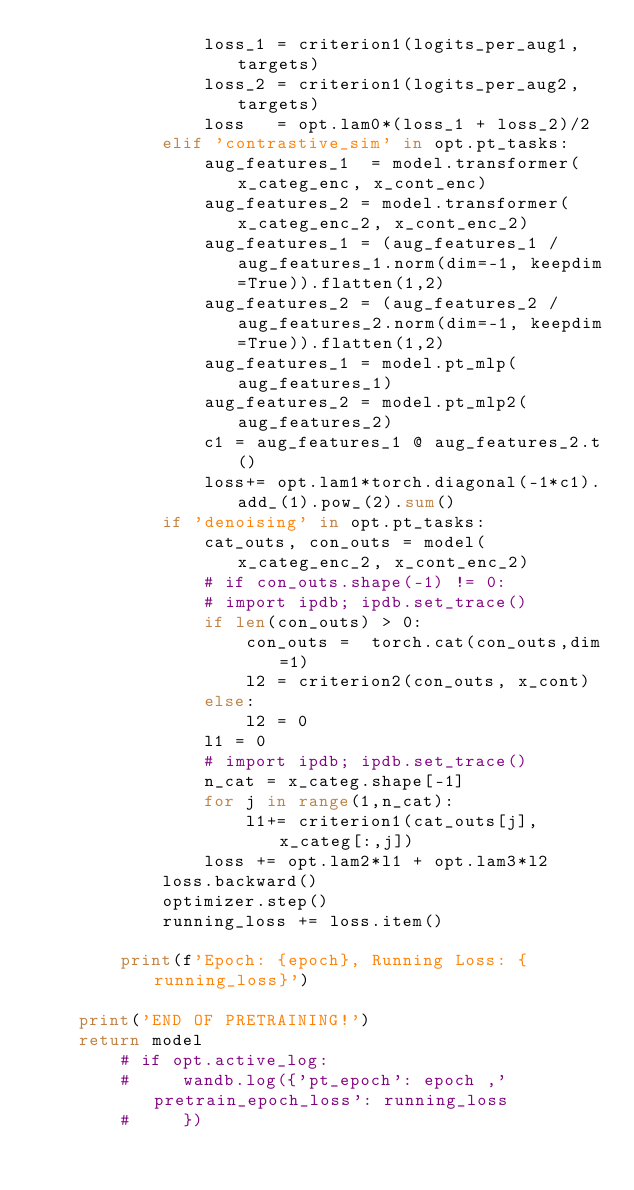<code> <loc_0><loc_0><loc_500><loc_500><_Python_>                loss_1 = criterion1(logits_per_aug1, targets)
                loss_2 = criterion1(logits_per_aug2, targets)
                loss   = opt.lam0*(loss_1 + loss_2)/2
            elif 'contrastive_sim' in opt.pt_tasks:
                aug_features_1  = model.transformer(x_categ_enc, x_cont_enc)
                aug_features_2 = model.transformer(x_categ_enc_2, x_cont_enc_2)
                aug_features_1 = (aug_features_1 / aug_features_1.norm(dim=-1, keepdim=True)).flatten(1,2)
                aug_features_2 = (aug_features_2 / aug_features_2.norm(dim=-1, keepdim=True)).flatten(1,2)
                aug_features_1 = model.pt_mlp(aug_features_1)
                aug_features_2 = model.pt_mlp2(aug_features_2)
                c1 = aug_features_1 @ aug_features_2.t()
                loss+= opt.lam1*torch.diagonal(-1*c1).add_(1).pow_(2).sum()
            if 'denoising' in opt.pt_tasks:
                cat_outs, con_outs = model(x_categ_enc_2, x_cont_enc_2)
                # if con_outs.shape(-1) != 0:
                # import ipdb; ipdb.set_trace()
                if len(con_outs) > 0:
                    con_outs =  torch.cat(con_outs,dim=1)
                    l2 = criterion2(con_outs, x_cont)
                else:
                    l2 = 0
                l1 = 0
                # import ipdb; ipdb.set_trace()
                n_cat = x_categ.shape[-1]
                for j in range(1,n_cat):
                    l1+= criterion1(cat_outs[j],x_categ[:,j])
                loss += opt.lam2*l1 + opt.lam3*l2    
            loss.backward()
            optimizer.step()
            running_loss += loss.item()
        
        print(f'Epoch: {epoch}, Running Loss: {running_loss}')

    print('END OF PRETRAINING!')
    return model
        # if opt.active_log:
        #     wandb.log({'pt_epoch': epoch ,'pretrain_epoch_loss': running_loss
        #     })
</code> 